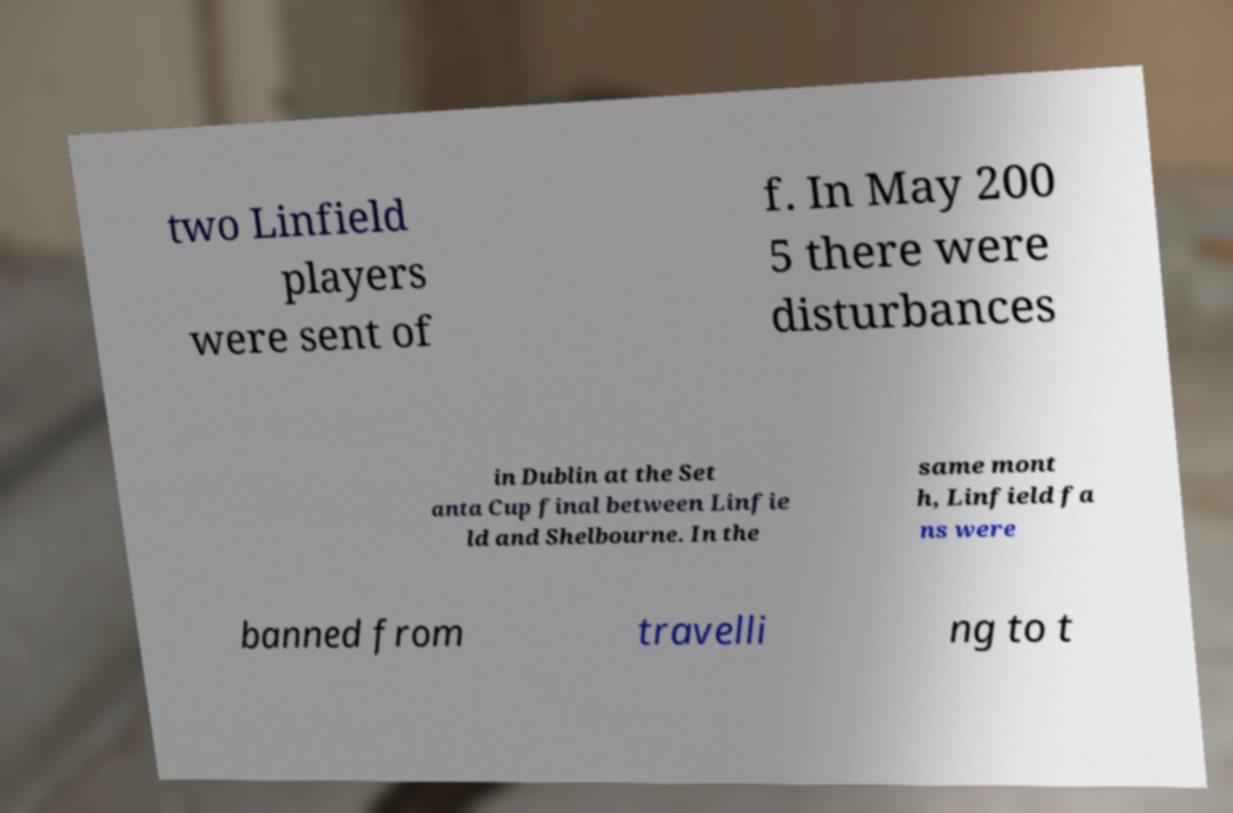For documentation purposes, I need the text within this image transcribed. Could you provide that? two Linfield players were sent of f. In May 200 5 there were disturbances in Dublin at the Set anta Cup final between Linfie ld and Shelbourne. In the same mont h, Linfield fa ns were banned from travelli ng to t 